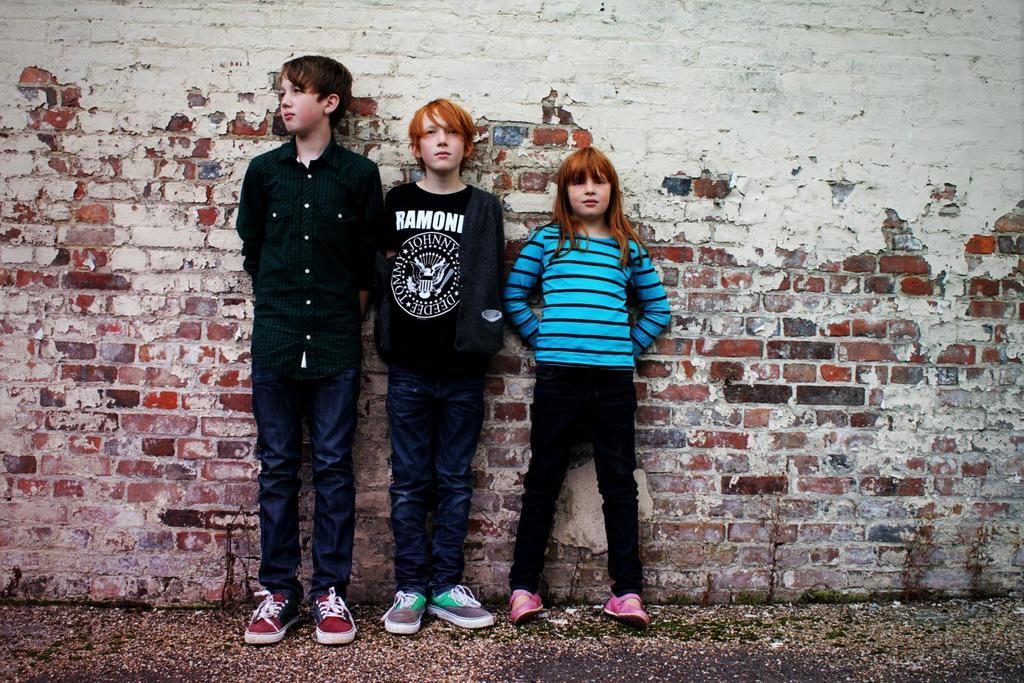Please provide a concise description of this image. In this picture we can see two boys and a girl wore shoes and standing on the ground and in the background we can see a brick wall. 